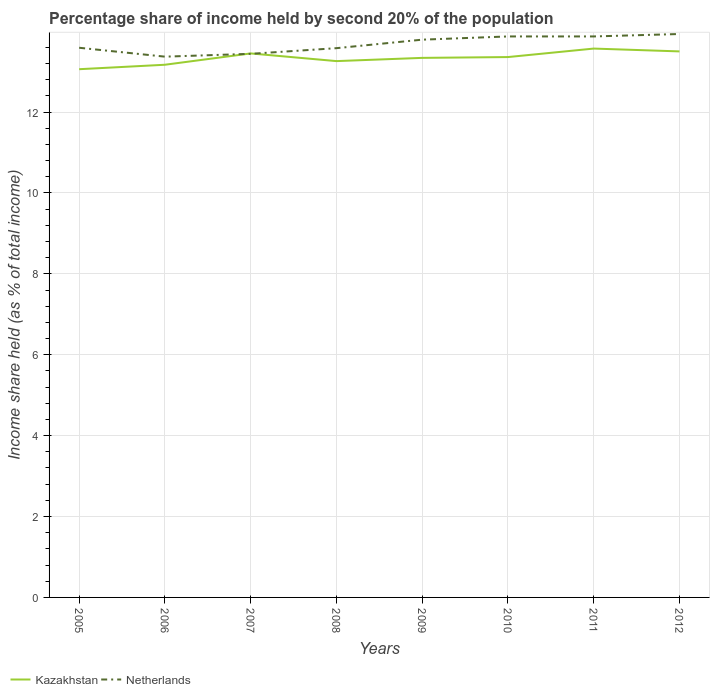Does the line corresponding to Netherlands intersect with the line corresponding to Kazakhstan?
Your answer should be very brief. Yes. Is the number of lines equal to the number of legend labels?
Make the answer very short. Yes. Across all years, what is the maximum share of income held by second 20% of the population in Netherlands?
Offer a terse response. 13.37. What is the total share of income held by second 20% of the population in Kazakhstan in the graph?
Keep it short and to the point. -0.12. What is the difference between the highest and the second highest share of income held by second 20% of the population in Kazakhstan?
Make the answer very short. 0.51. Is the share of income held by second 20% of the population in Netherlands strictly greater than the share of income held by second 20% of the population in Kazakhstan over the years?
Your answer should be very brief. No. How many years are there in the graph?
Provide a short and direct response. 8. Where does the legend appear in the graph?
Offer a very short reply. Bottom left. How many legend labels are there?
Your answer should be very brief. 2. What is the title of the graph?
Give a very brief answer. Percentage share of income held by second 20% of the population. Does "Iran" appear as one of the legend labels in the graph?
Offer a terse response. No. What is the label or title of the Y-axis?
Give a very brief answer. Income share held (as % of total income). What is the Income share held (as % of total income) in Kazakhstan in 2005?
Provide a succinct answer. 13.06. What is the Income share held (as % of total income) of Netherlands in 2005?
Keep it short and to the point. 13.59. What is the Income share held (as % of total income) of Kazakhstan in 2006?
Ensure brevity in your answer.  13.17. What is the Income share held (as % of total income) of Netherlands in 2006?
Your response must be concise. 13.37. What is the Income share held (as % of total income) in Kazakhstan in 2007?
Offer a very short reply. 13.45. What is the Income share held (as % of total income) of Netherlands in 2007?
Your response must be concise. 13.44. What is the Income share held (as % of total income) of Kazakhstan in 2008?
Give a very brief answer. 13.26. What is the Income share held (as % of total income) of Netherlands in 2008?
Provide a succinct answer. 13.58. What is the Income share held (as % of total income) in Kazakhstan in 2009?
Provide a succinct answer. 13.34. What is the Income share held (as % of total income) of Netherlands in 2009?
Make the answer very short. 13.79. What is the Income share held (as % of total income) of Kazakhstan in 2010?
Give a very brief answer. 13.36. What is the Income share held (as % of total income) of Netherlands in 2010?
Your response must be concise. 13.87. What is the Income share held (as % of total income) in Kazakhstan in 2011?
Offer a terse response. 13.57. What is the Income share held (as % of total income) in Netherlands in 2011?
Ensure brevity in your answer.  13.87. What is the Income share held (as % of total income) of Kazakhstan in 2012?
Offer a terse response. 13.5. What is the Income share held (as % of total income) in Netherlands in 2012?
Provide a short and direct response. 13.93. Across all years, what is the maximum Income share held (as % of total income) of Kazakhstan?
Ensure brevity in your answer.  13.57. Across all years, what is the maximum Income share held (as % of total income) in Netherlands?
Your answer should be compact. 13.93. Across all years, what is the minimum Income share held (as % of total income) of Kazakhstan?
Provide a short and direct response. 13.06. Across all years, what is the minimum Income share held (as % of total income) of Netherlands?
Your answer should be very brief. 13.37. What is the total Income share held (as % of total income) of Kazakhstan in the graph?
Make the answer very short. 106.71. What is the total Income share held (as % of total income) in Netherlands in the graph?
Provide a short and direct response. 109.44. What is the difference between the Income share held (as % of total income) of Kazakhstan in 2005 and that in 2006?
Keep it short and to the point. -0.11. What is the difference between the Income share held (as % of total income) in Netherlands in 2005 and that in 2006?
Make the answer very short. 0.22. What is the difference between the Income share held (as % of total income) of Kazakhstan in 2005 and that in 2007?
Your answer should be compact. -0.39. What is the difference between the Income share held (as % of total income) in Netherlands in 2005 and that in 2008?
Your answer should be very brief. 0.01. What is the difference between the Income share held (as % of total income) of Kazakhstan in 2005 and that in 2009?
Offer a very short reply. -0.28. What is the difference between the Income share held (as % of total income) of Netherlands in 2005 and that in 2009?
Your answer should be very brief. -0.2. What is the difference between the Income share held (as % of total income) in Netherlands in 2005 and that in 2010?
Your answer should be compact. -0.28. What is the difference between the Income share held (as % of total income) in Kazakhstan in 2005 and that in 2011?
Ensure brevity in your answer.  -0.51. What is the difference between the Income share held (as % of total income) of Netherlands in 2005 and that in 2011?
Keep it short and to the point. -0.28. What is the difference between the Income share held (as % of total income) of Kazakhstan in 2005 and that in 2012?
Your answer should be very brief. -0.44. What is the difference between the Income share held (as % of total income) in Netherlands in 2005 and that in 2012?
Ensure brevity in your answer.  -0.34. What is the difference between the Income share held (as % of total income) in Kazakhstan in 2006 and that in 2007?
Offer a terse response. -0.28. What is the difference between the Income share held (as % of total income) of Netherlands in 2006 and that in 2007?
Give a very brief answer. -0.07. What is the difference between the Income share held (as % of total income) of Kazakhstan in 2006 and that in 2008?
Your answer should be very brief. -0.09. What is the difference between the Income share held (as % of total income) of Netherlands in 2006 and that in 2008?
Your response must be concise. -0.21. What is the difference between the Income share held (as % of total income) in Kazakhstan in 2006 and that in 2009?
Offer a very short reply. -0.17. What is the difference between the Income share held (as % of total income) in Netherlands in 2006 and that in 2009?
Give a very brief answer. -0.42. What is the difference between the Income share held (as % of total income) in Kazakhstan in 2006 and that in 2010?
Your answer should be very brief. -0.19. What is the difference between the Income share held (as % of total income) of Netherlands in 2006 and that in 2010?
Ensure brevity in your answer.  -0.5. What is the difference between the Income share held (as % of total income) in Kazakhstan in 2006 and that in 2011?
Provide a succinct answer. -0.4. What is the difference between the Income share held (as % of total income) in Kazakhstan in 2006 and that in 2012?
Provide a succinct answer. -0.33. What is the difference between the Income share held (as % of total income) in Netherlands in 2006 and that in 2012?
Your answer should be very brief. -0.56. What is the difference between the Income share held (as % of total income) of Kazakhstan in 2007 and that in 2008?
Give a very brief answer. 0.19. What is the difference between the Income share held (as % of total income) of Netherlands in 2007 and that in 2008?
Offer a very short reply. -0.14. What is the difference between the Income share held (as % of total income) of Kazakhstan in 2007 and that in 2009?
Offer a very short reply. 0.11. What is the difference between the Income share held (as % of total income) of Netherlands in 2007 and that in 2009?
Keep it short and to the point. -0.35. What is the difference between the Income share held (as % of total income) of Kazakhstan in 2007 and that in 2010?
Make the answer very short. 0.09. What is the difference between the Income share held (as % of total income) in Netherlands in 2007 and that in 2010?
Give a very brief answer. -0.43. What is the difference between the Income share held (as % of total income) in Kazakhstan in 2007 and that in 2011?
Give a very brief answer. -0.12. What is the difference between the Income share held (as % of total income) of Netherlands in 2007 and that in 2011?
Ensure brevity in your answer.  -0.43. What is the difference between the Income share held (as % of total income) in Kazakhstan in 2007 and that in 2012?
Provide a short and direct response. -0.05. What is the difference between the Income share held (as % of total income) in Netherlands in 2007 and that in 2012?
Provide a succinct answer. -0.49. What is the difference between the Income share held (as % of total income) in Kazakhstan in 2008 and that in 2009?
Offer a terse response. -0.08. What is the difference between the Income share held (as % of total income) of Netherlands in 2008 and that in 2009?
Your answer should be very brief. -0.21. What is the difference between the Income share held (as % of total income) of Netherlands in 2008 and that in 2010?
Your response must be concise. -0.29. What is the difference between the Income share held (as % of total income) of Kazakhstan in 2008 and that in 2011?
Ensure brevity in your answer.  -0.31. What is the difference between the Income share held (as % of total income) of Netherlands in 2008 and that in 2011?
Keep it short and to the point. -0.29. What is the difference between the Income share held (as % of total income) of Kazakhstan in 2008 and that in 2012?
Offer a terse response. -0.24. What is the difference between the Income share held (as % of total income) in Netherlands in 2008 and that in 2012?
Provide a short and direct response. -0.35. What is the difference between the Income share held (as % of total income) in Kazakhstan in 2009 and that in 2010?
Provide a succinct answer. -0.02. What is the difference between the Income share held (as % of total income) of Netherlands in 2009 and that in 2010?
Your response must be concise. -0.08. What is the difference between the Income share held (as % of total income) of Kazakhstan in 2009 and that in 2011?
Offer a terse response. -0.23. What is the difference between the Income share held (as % of total income) in Netherlands in 2009 and that in 2011?
Your answer should be compact. -0.08. What is the difference between the Income share held (as % of total income) in Kazakhstan in 2009 and that in 2012?
Provide a short and direct response. -0.16. What is the difference between the Income share held (as % of total income) of Netherlands in 2009 and that in 2012?
Offer a very short reply. -0.14. What is the difference between the Income share held (as % of total income) in Kazakhstan in 2010 and that in 2011?
Offer a terse response. -0.21. What is the difference between the Income share held (as % of total income) in Kazakhstan in 2010 and that in 2012?
Your answer should be compact. -0.14. What is the difference between the Income share held (as % of total income) of Netherlands in 2010 and that in 2012?
Make the answer very short. -0.06. What is the difference between the Income share held (as % of total income) in Kazakhstan in 2011 and that in 2012?
Offer a very short reply. 0.07. What is the difference between the Income share held (as % of total income) of Netherlands in 2011 and that in 2012?
Make the answer very short. -0.06. What is the difference between the Income share held (as % of total income) in Kazakhstan in 2005 and the Income share held (as % of total income) in Netherlands in 2006?
Provide a succinct answer. -0.31. What is the difference between the Income share held (as % of total income) in Kazakhstan in 2005 and the Income share held (as % of total income) in Netherlands in 2007?
Your response must be concise. -0.38. What is the difference between the Income share held (as % of total income) of Kazakhstan in 2005 and the Income share held (as % of total income) of Netherlands in 2008?
Ensure brevity in your answer.  -0.52. What is the difference between the Income share held (as % of total income) of Kazakhstan in 2005 and the Income share held (as % of total income) of Netherlands in 2009?
Ensure brevity in your answer.  -0.73. What is the difference between the Income share held (as % of total income) in Kazakhstan in 2005 and the Income share held (as % of total income) in Netherlands in 2010?
Ensure brevity in your answer.  -0.81. What is the difference between the Income share held (as % of total income) in Kazakhstan in 2005 and the Income share held (as % of total income) in Netherlands in 2011?
Your response must be concise. -0.81. What is the difference between the Income share held (as % of total income) in Kazakhstan in 2005 and the Income share held (as % of total income) in Netherlands in 2012?
Your answer should be very brief. -0.87. What is the difference between the Income share held (as % of total income) of Kazakhstan in 2006 and the Income share held (as % of total income) of Netherlands in 2007?
Make the answer very short. -0.27. What is the difference between the Income share held (as % of total income) in Kazakhstan in 2006 and the Income share held (as % of total income) in Netherlands in 2008?
Give a very brief answer. -0.41. What is the difference between the Income share held (as % of total income) of Kazakhstan in 2006 and the Income share held (as % of total income) of Netherlands in 2009?
Provide a succinct answer. -0.62. What is the difference between the Income share held (as % of total income) of Kazakhstan in 2006 and the Income share held (as % of total income) of Netherlands in 2012?
Give a very brief answer. -0.76. What is the difference between the Income share held (as % of total income) in Kazakhstan in 2007 and the Income share held (as % of total income) in Netherlands in 2008?
Offer a terse response. -0.13. What is the difference between the Income share held (as % of total income) of Kazakhstan in 2007 and the Income share held (as % of total income) of Netherlands in 2009?
Your answer should be compact. -0.34. What is the difference between the Income share held (as % of total income) of Kazakhstan in 2007 and the Income share held (as % of total income) of Netherlands in 2010?
Provide a succinct answer. -0.42. What is the difference between the Income share held (as % of total income) in Kazakhstan in 2007 and the Income share held (as % of total income) in Netherlands in 2011?
Your answer should be compact. -0.42. What is the difference between the Income share held (as % of total income) of Kazakhstan in 2007 and the Income share held (as % of total income) of Netherlands in 2012?
Provide a succinct answer. -0.48. What is the difference between the Income share held (as % of total income) of Kazakhstan in 2008 and the Income share held (as % of total income) of Netherlands in 2009?
Make the answer very short. -0.53. What is the difference between the Income share held (as % of total income) of Kazakhstan in 2008 and the Income share held (as % of total income) of Netherlands in 2010?
Provide a short and direct response. -0.61. What is the difference between the Income share held (as % of total income) of Kazakhstan in 2008 and the Income share held (as % of total income) of Netherlands in 2011?
Offer a terse response. -0.61. What is the difference between the Income share held (as % of total income) of Kazakhstan in 2008 and the Income share held (as % of total income) of Netherlands in 2012?
Provide a succinct answer. -0.67. What is the difference between the Income share held (as % of total income) of Kazakhstan in 2009 and the Income share held (as % of total income) of Netherlands in 2010?
Give a very brief answer. -0.53. What is the difference between the Income share held (as % of total income) of Kazakhstan in 2009 and the Income share held (as % of total income) of Netherlands in 2011?
Your answer should be very brief. -0.53. What is the difference between the Income share held (as % of total income) in Kazakhstan in 2009 and the Income share held (as % of total income) in Netherlands in 2012?
Keep it short and to the point. -0.59. What is the difference between the Income share held (as % of total income) of Kazakhstan in 2010 and the Income share held (as % of total income) of Netherlands in 2011?
Make the answer very short. -0.51. What is the difference between the Income share held (as % of total income) of Kazakhstan in 2010 and the Income share held (as % of total income) of Netherlands in 2012?
Keep it short and to the point. -0.57. What is the difference between the Income share held (as % of total income) in Kazakhstan in 2011 and the Income share held (as % of total income) in Netherlands in 2012?
Give a very brief answer. -0.36. What is the average Income share held (as % of total income) of Kazakhstan per year?
Make the answer very short. 13.34. What is the average Income share held (as % of total income) of Netherlands per year?
Offer a terse response. 13.68. In the year 2005, what is the difference between the Income share held (as % of total income) of Kazakhstan and Income share held (as % of total income) of Netherlands?
Your answer should be compact. -0.53. In the year 2006, what is the difference between the Income share held (as % of total income) of Kazakhstan and Income share held (as % of total income) of Netherlands?
Give a very brief answer. -0.2. In the year 2007, what is the difference between the Income share held (as % of total income) in Kazakhstan and Income share held (as % of total income) in Netherlands?
Offer a very short reply. 0.01. In the year 2008, what is the difference between the Income share held (as % of total income) in Kazakhstan and Income share held (as % of total income) in Netherlands?
Your answer should be compact. -0.32. In the year 2009, what is the difference between the Income share held (as % of total income) of Kazakhstan and Income share held (as % of total income) of Netherlands?
Give a very brief answer. -0.45. In the year 2010, what is the difference between the Income share held (as % of total income) of Kazakhstan and Income share held (as % of total income) of Netherlands?
Make the answer very short. -0.51. In the year 2012, what is the difference between the Income share held (as % of total income) of Kazakhstan and Income share held (as % of total income) of Netherlands?
Provide a short and direct response. -0.43. What is the ratio of the Income share held (as % of total income) in Netherlands in 2005 to that in 2006?
Your answer should be very brief. 1.02. What is the ratio of the Income share held (as % of total income) of Kazakhstan in 2005 to that in 2007?
Your answer should be very brief. 0.97. What is the ratio of the Income share held (as % of total income) in Netherlands in 2005 to that in 2007?
Your answer should be very brief. 1.01. What is the ratio of the Income share held (as % of total income) in Kazakhstan in 2005 to that in 2008?
Offer a terse response. 0.98. What is the ratio of the Income share held (as % of total income) of Kazakhstan in 2005 to that in 2009?
Your answer should be very brief. 0.98. What is the ratio of the Income share held (as % of total income) in Netherlands in 2005 to that in 2009?
Keep it short and to the point. 0.99. What is the ratio of the Income share held (as % of total income) in Kazakhstan in 2005 to that in 2010?
Give a very brief answer. 0.98. What is the ratio of the Income share held (as % of total income) of Netherlands in 2005 to that in 2010?
Provide a short and direct response. 0.98. What is the ratio of the Income share held (as % of total income) of Kazakhstan in 2005 to that in 2011?
Offer a terse response. 0.96. What is the ratio of the Income share held (as % of total income) in Netherlands in 2005 to that in 2011?
Ensure brevity in your answer.  0.98. What is the ratio of the Income share held (as % of total income) of Kazakhstan in 2005 to that in 2012?
Offer a very short reply. 0.97. What is the ratio of the Income share held (as % of total income) in Netherlands in 2005 to that in 2012?
Offer a terse response. 0.98. What is the ratio of the Income share held (as % of total income) of Kazakhstan in 2006 to that in 2007?
Your answer should be very brief. 0.98. What is the ratio of the Income share held (as % of total income) of Netherlands in 2006 to that in 2007?
Your response must be concise. 0.99. What is the ratio of the Income share held (as % of total income) of Netherlands in 2006 to that in 2008?
Make the answer very short. 0.98. What is the ratio of the Income share held (as % of total income) of Kazakhstan in 2006 to that in 2009?
Your answer should be very brief. 0.99. What is the ratio of the Income share held (as % of total income) in Netherlands in 2006 to that in 2009?
Provide a succinct answer. 0.97. What is the ratio of the Income share held (as % of total income) of Kazakhstan in 2006 to that in 2010?
Offer a terse response. 0.99. What is the ratio of the Income share held (as % of total income) of Kazakhstan in 2006 to that in 2011?
Offer a terse response. 0.97. What is the ratio of the Income share held (as % of total income) of Netherlands in 2006 to that in 2011?
Provide a succinct answer. 0.96. What is the ratio of the Income share held (as % of total income) of Kazakhstan in 2006 to that in 2012?
Your answer should be compact. 0.98. What is the ratio of the Income share held (as % of total income) in Netherlands in 2006 to that in 2012?
Make the answer very short. 0.96. What is the ratio of the Income share held (as % of total income) in Kazakhstan in 2007 to that in 2008?
Provide a short and direct response. 1.01. What is the ratio of the Income share held (as % of total income) of Kazakhstan in 2007 to that in 2009?
Your answer should be compact. 1.01. What is the ratio of the Income share held (as % of total income) of Netherlands in 2007 to that in 2009?
Your response must be concise. 0.97. What is the ratio of the Income share held (as % of total income) in Netherlands in 2007 to that in 2010?
Ensure brevity in your answer.  0.97. What is the ratio of the Income share held (as % of total income) of Kazakhstan in 2007 to that in 2011?
Your answer should be very brief. 0.99. What is the ratio of the Income share held (as % of total income) in Netherlands in 2007 to that in 2011?
Offer a terse response. 0.97. What is the ratio of the Income share held (as % of total income) in Kazakhstan in 2007 to that in 2012?
Offer a very short reply. 1. What is the ratio of the Income share held (as % of total income) of Netherlands in 2007 to that in 2012?
Your response must be concise. 0.96. What is the ratio of the Income share held (as % of total income) in Netherlands in 2008 to that in 2010?
Offer a very short reply. 0.98. What is the ratio of the Income share held (as % of total income) of Kazakhstan in 2008 to that in 2011?
Ensure brevity in your answer.  0.98. What is the ratio of the Income share held (as % of total income) of Netherlands in 2008 to that in 2011?
Offer a terse response. 0.98. What is the ratio of the Income share held (as % of total income) of Kazakhstan in 2008 to that in 2012?
Your answer should be very brief. 0.98. What is the ratio of the Income share held (as % of total income) in Netherlands in 2008 to that in 2012?
Your answer should be compact. 0.97. What is the ratio of the Income share held (as % of total income) of Kazakhstan in 2009 to that in 2010?
Offer a very short reply. 1. What is the ratio of the Income share held (as % of total income) in Netherlands in 2009 to that in 2010?
Your response must be concise. 0.99. What is the ratio of the Income share held (as % of total income) in Kazakhstan in 2009 to that in 2011?
Provide a succinct answer. 0.98. What is the ratio of the Income share held (as % of total income) of Kazakhstan in 2009 to that in 2012?
Provide a short and direct response. 0.99. What is the ratio of the Income share held (as % of total income) of Kazakhstan in 2010 to that in 2011?
Your response must be concise. 0.98. What is the ratio of the Income share held (as % of total income) in Kazakhstan in 2011 to that in 2012?
Your answer should be compact. 1.01. What is the ratio of the Income share held (as % of total income) of Netherlands in 2011 to that in 2012?
Offer a terse response. 1. What is the difference between the highest and the second highest Income share held (as % of total income) of Kazakhstan?
Give a very brief answer. 0.07. What is the difference between the highest and the lowest Income share held (as % of total income) in Kazakhstan?
Provide a short and direct response. 0.51. What is the difference between the highest and the lowest Income share held (as % of total income) in Netherlands?
Provide a succinct answer. 0.56. 